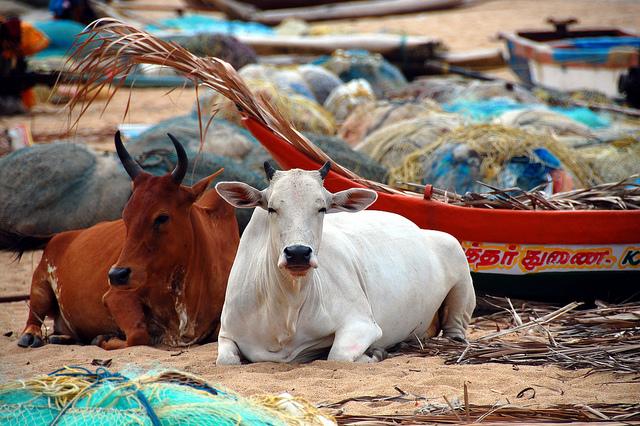<image>Are the animals the same color? I don't know if the animals are the same color as it is ambiguous without seeing an image. Are the animals the same color? The animals are not the same color. 